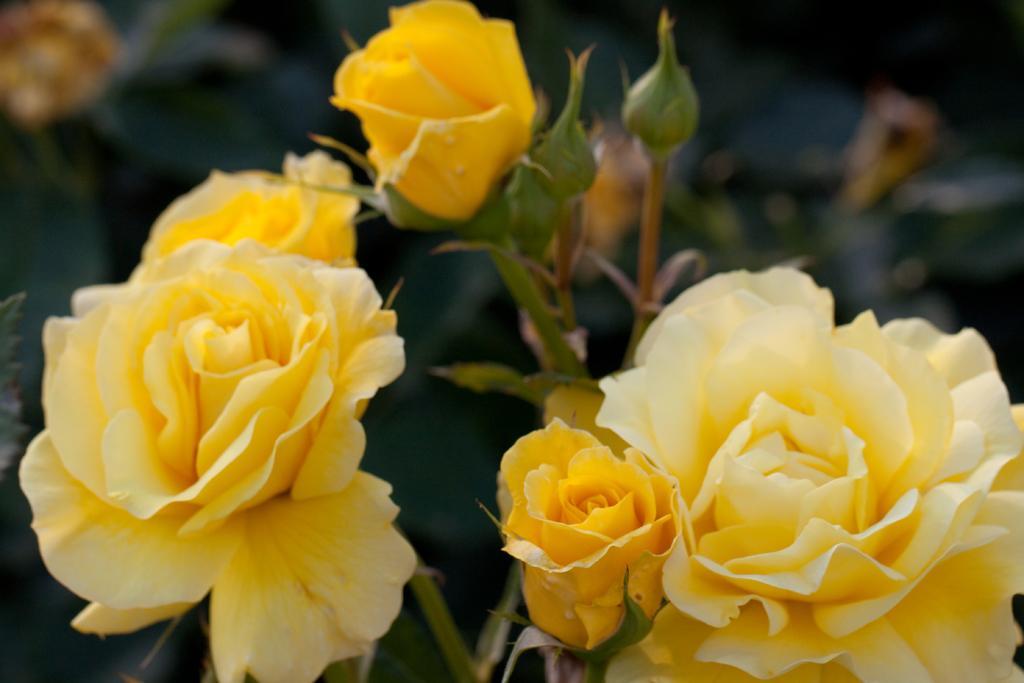How would you summarize this image in a sentence or two? In this image I see flowers which are of yellow in color and I see the stems and buds and it is blurred in the background. 